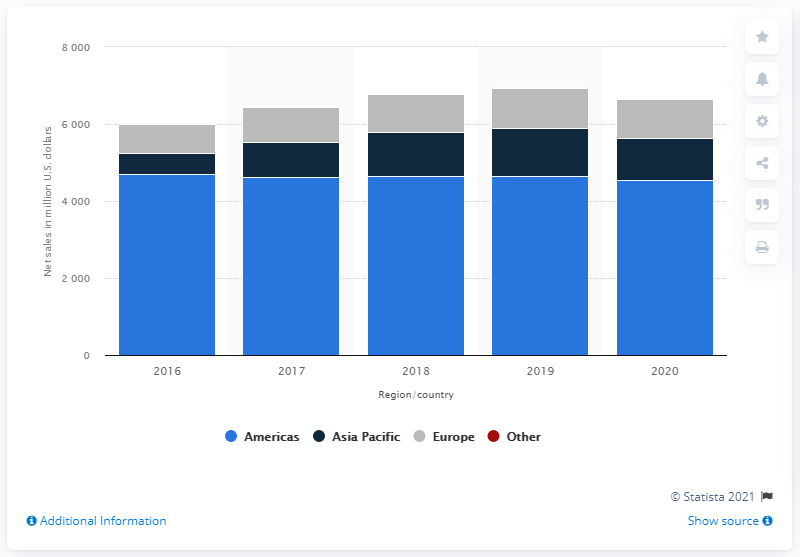Draw attention to some important aspects in this diagram. Hanesbrands' net sales in the Americas in 2020 were $454.44 million. 